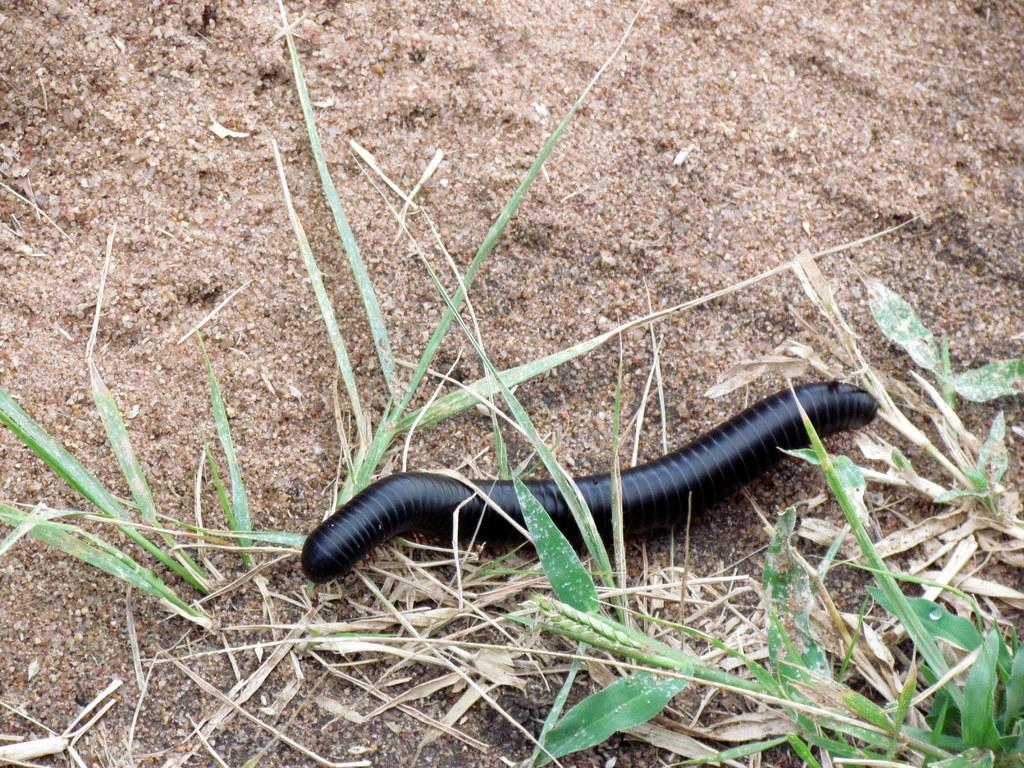What type of creature is in the picture? There is an insect in the picture. Where is the insect located? The insect is on the floor. What type of surface can be seen in the picture? There is soil in the picture. What type of vegetation is present in the image? There is grass in the picture. Can you tell me how many mint leaves are on the shelf in the image? There is no shelf or mint leaves present in the image. 